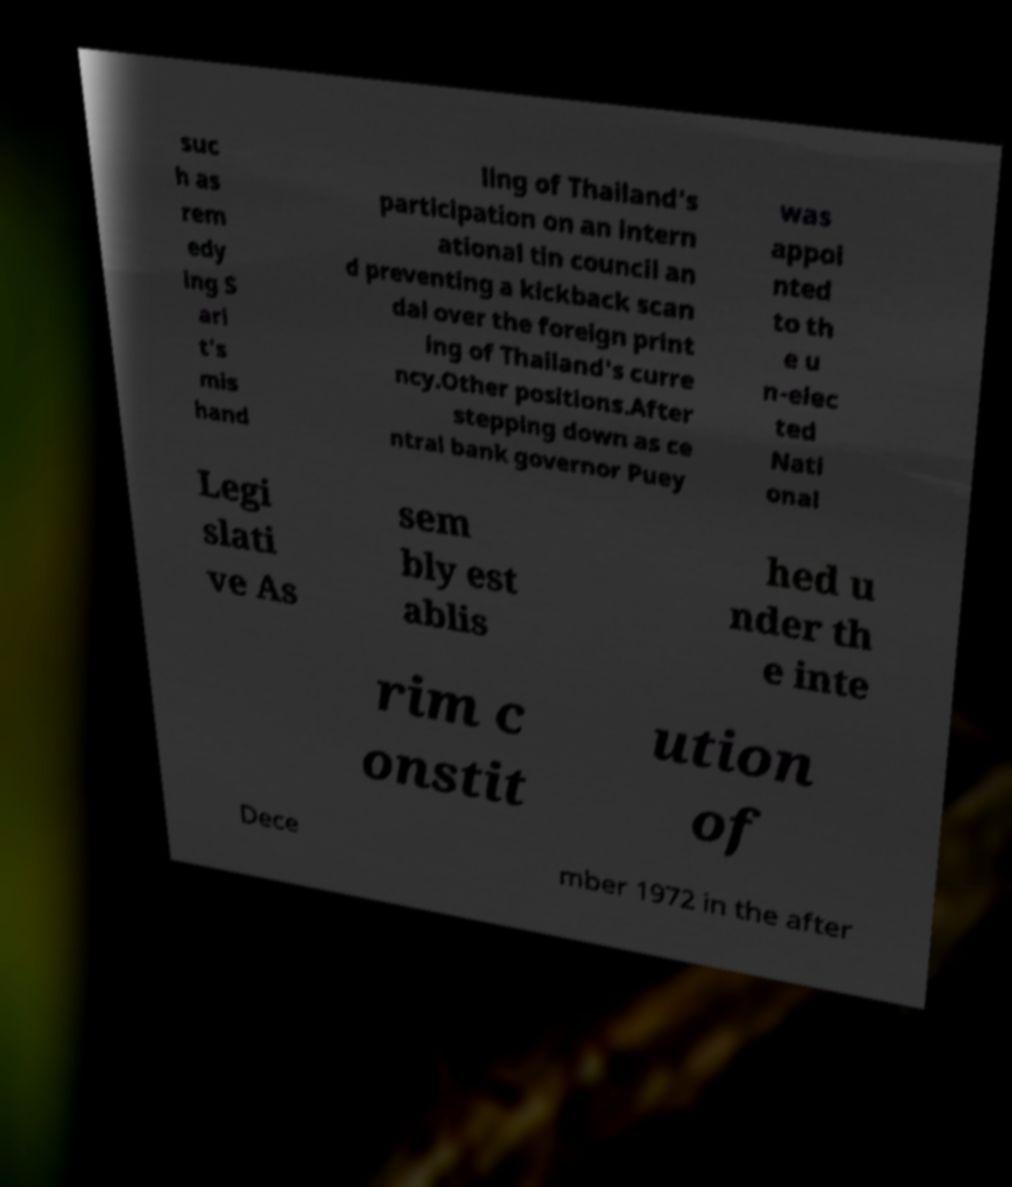Could you extract and type out the text from this image? suc h as rem edy ing S ari t's mis hand ling of Thailand's participation on an intern ational tin council an d preventing a kickback scan dal over the foreign print ing of Thailand's curre ncy.Other positions.After stepping down as ce ntral bank governor Puey was appoi nted to th e u n-elec ted Nati onal Legi slati ve As sem bly est ablis hed u nder th e inte rim c onstit ution of Dece mber 1972 in the after 